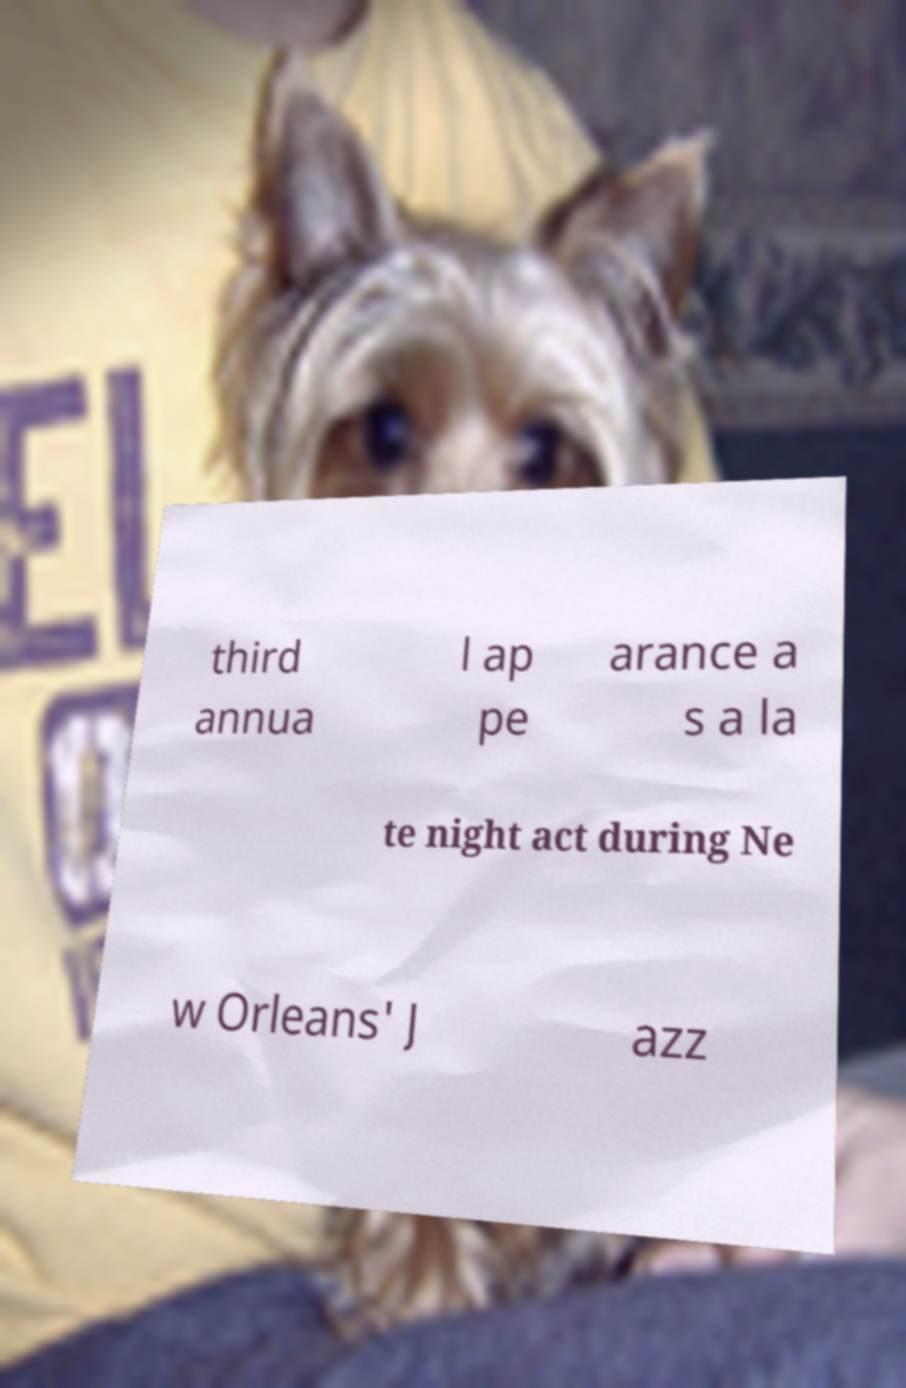Please identify and transcribe the text found in this image. third annua l ap pe arance a s a la te night act during Ne w Orleans' J azz 